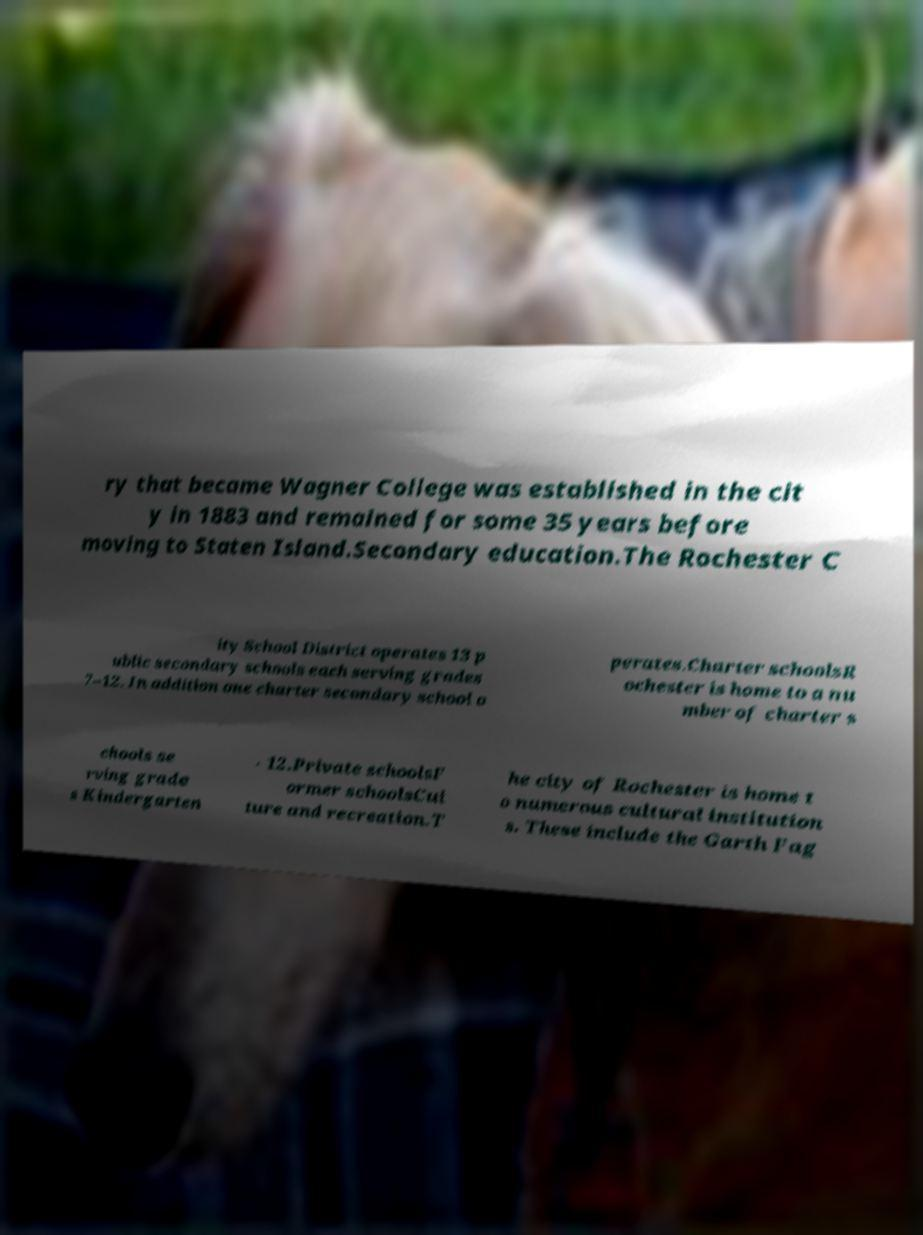Can you read and provide the text displayed in the image?This photo seems to have some interesting text. Can you extract and type it out for me? ry that became Wagner College was established in the cit y in 1883 and remained for some 35 years before moving to Staten Island.Secondary education.The Rochester C ity School District operates 13 p ublic secondary schools each serving grades 7–12. In addition one charter secondary school o perates.Charter schoolsR ochester is home to a nu mber of charter s chools se rving grade s Kindergarten - 12.Private schoolsF ormer schoolsCul ture and recreation.T he city of Rochester is home t o numerous cultural institution s. These include the Garth Fag 